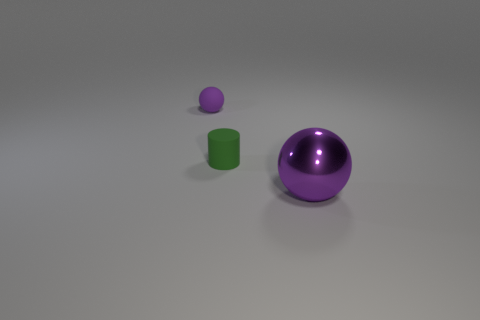Add 1 small blue rubber cubes. How many objects exist? 4 Subtract 1 green cylinders. How many objects are left? 2 Subtract all cylinders. How many objects are left? 2 Subtract all small brown rubber things. Subtract all tiny purple spheres. How many objects are left? 2 Add 3 large things. How many large things are left? 4 Add 1 purple spheres. How many purple spheres exist? 3 